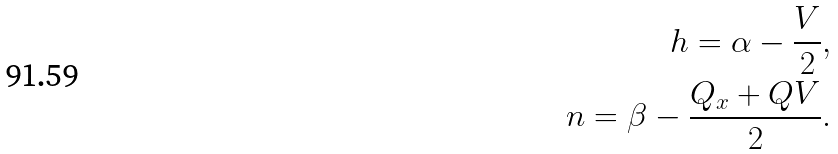<formula> <loc_0><loc_0><loc_500><loc_500>h = \alpha - \frac { V } { 2 } , \\ n = \beta - \frac { Q _ { x } + Q V } { 2 } .</formula> 